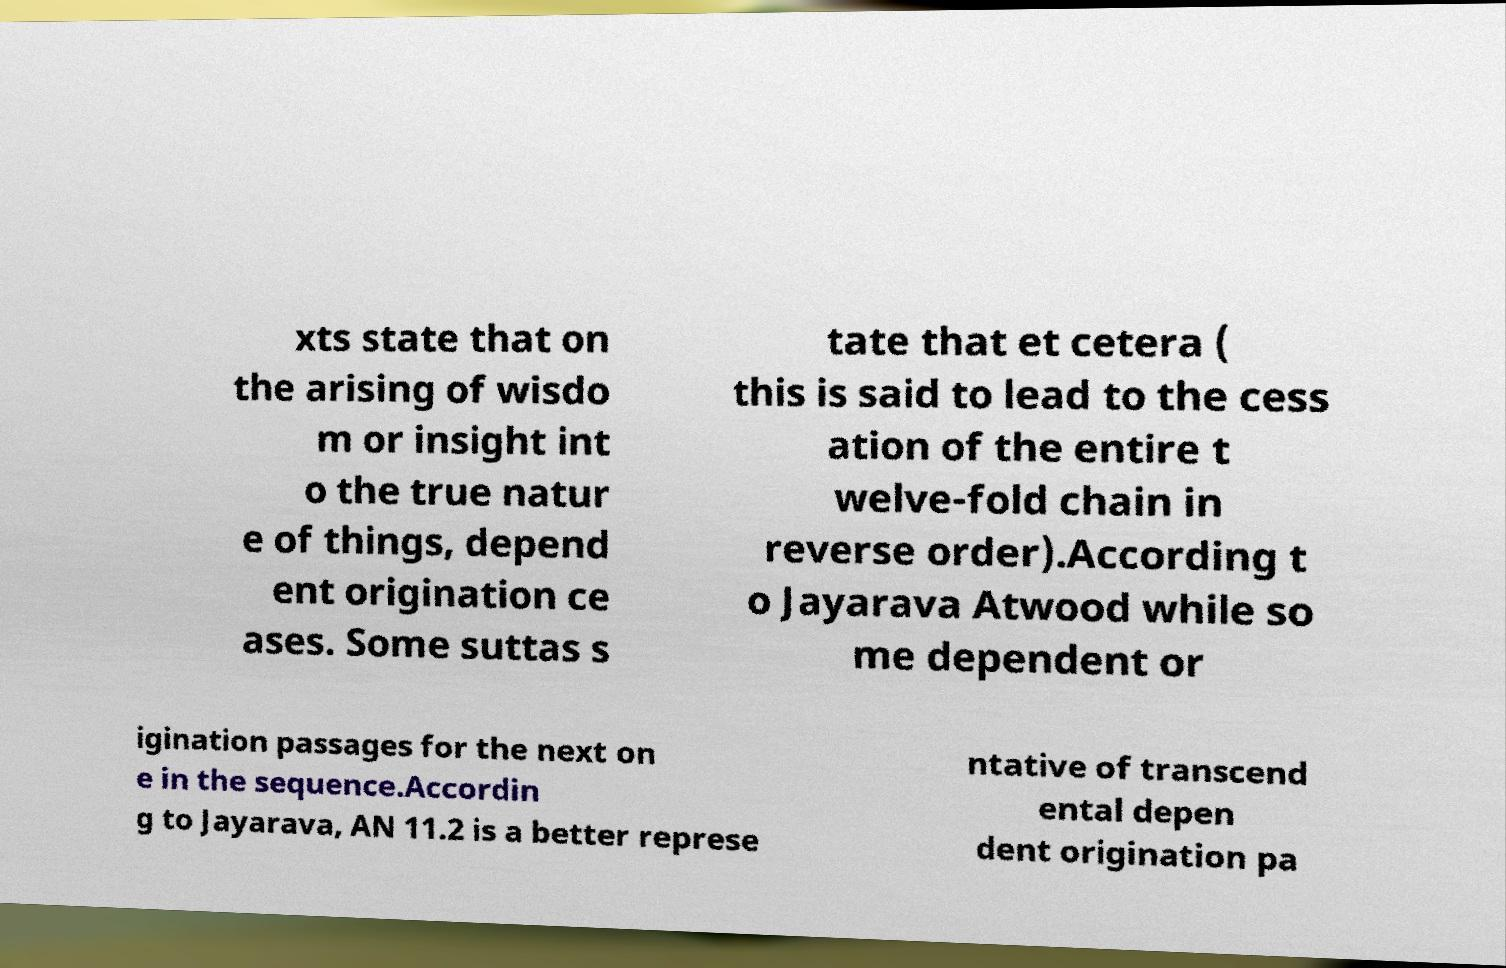Can you accurately transcribe the text from the provided image for me? xts state that on the arising of wisdo m or insight int o the true natur e of things, depend ent origination ce ases. Some suttas s tate that et cetera ( this is said to lead to the cess ation of the entire t welve-fold chain in reverse order).According t o Jayarava Atwood while so me dependent or igination passages for the next on e in the sequence.Accordin g to Jayarava, AN 11.2 is a better represe ntative of transcend ental depen dent origination pa 